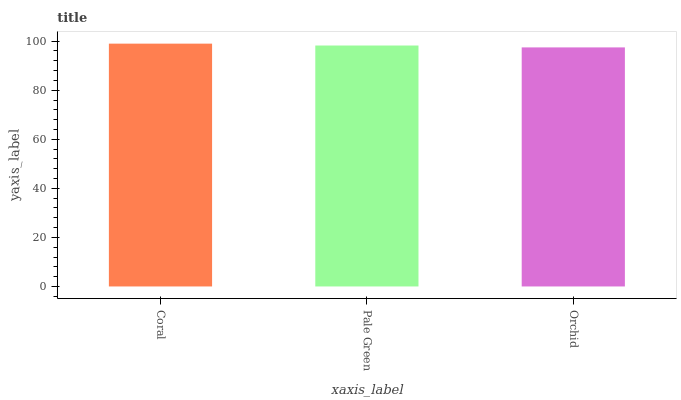Is Pale Green the minimum?
Answer yes or no. No. Is Pale Green the maximum?
Answer yes or no. No. Is Coral greater than Pale Green?
Answer yes or no. Yes. Is Pale Green less than Coral?
Answer yes or no. Yes. Is Pale Green greater than Coral?
Answer yes or no. No. Is Coral less than Pale Green?
Answer yes or no. No. Is Pale Green the high median?
Answer yes or no. Yes. Is Pale Green the low median?
Answer yes or no. Yes. Is Coral the high median?
Answer yes or no. No. Is Orchid the low median?
Answer yes or no. No. 